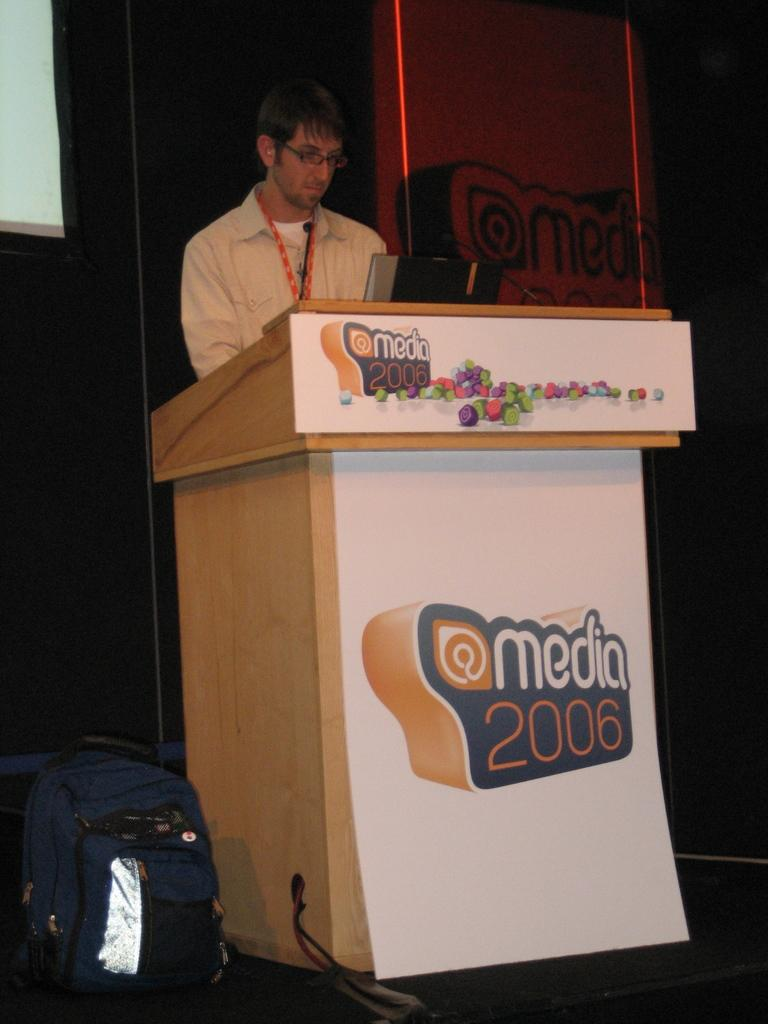What is the man doing in the image? The man is standing in front of the podium. What is on the floor near the man? There is a bag on the floor. Where is the bag located in relation to the man? The bag is in front of the man. What is on the table or surface in front of the man? There is a laptop in front of the man. What can be seen in the background of the image? There is a screen visible in the background. What type of animal is being sold at the market in the image? There is no market or animal present in the image. What is the current rate of the item being discussed in the image? There is no discussion or item with a rate present in the image. 